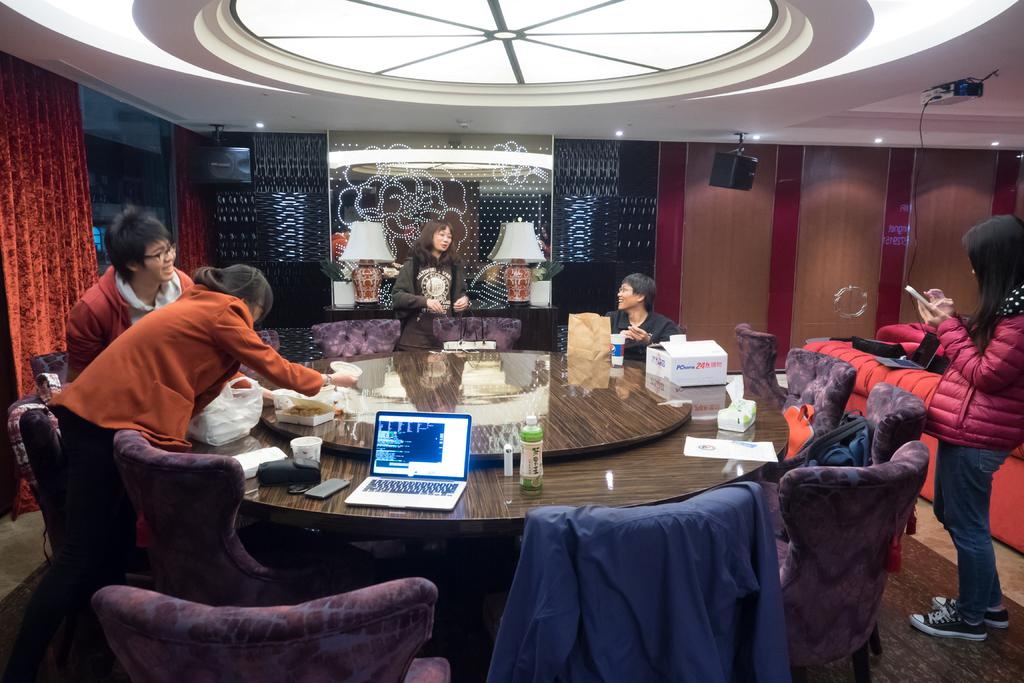What are the people in the image doing? People are sitting on chairs in the image. What can be seen on the table in the image? There is a laptop, a box, and papers on the table in the image. What are the girls in the image doing? Girls are standing in the image. What is visible in the background of the image? There is a glass and a curtain in the background of the image. What type of advertisement can be seen on the camera in the image? There is no camera present in the image, so no advertisement can be seen. 